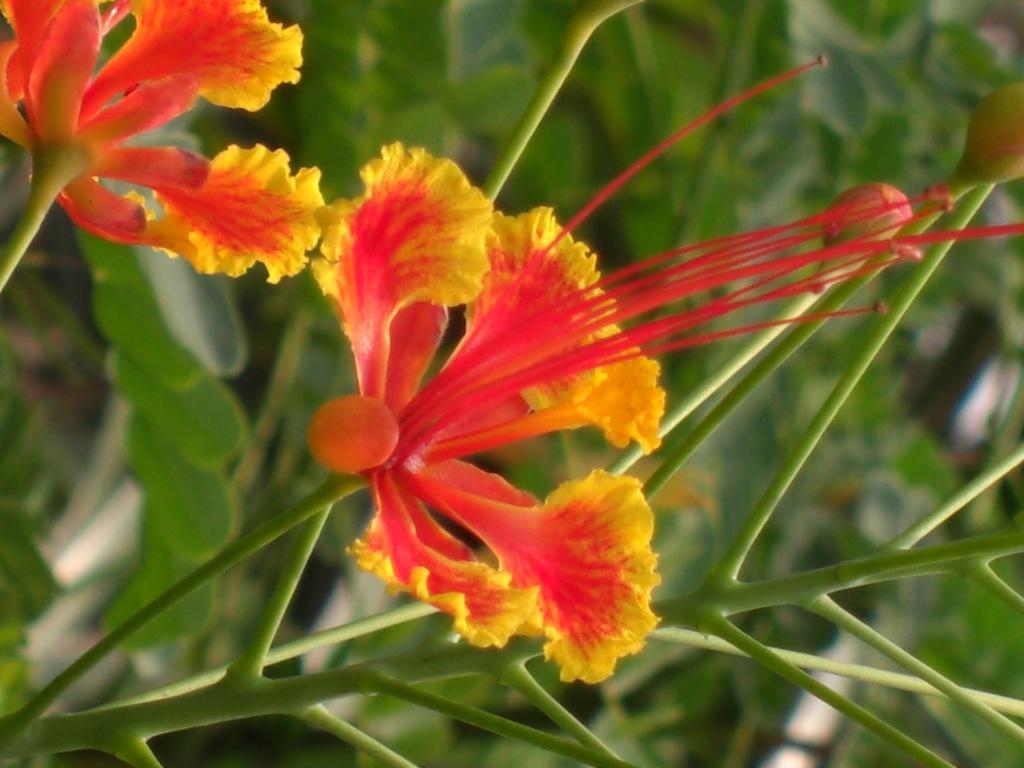Describe this image in one or two sentences. In this picture there are flowers on the plant. At the back there are plants. 